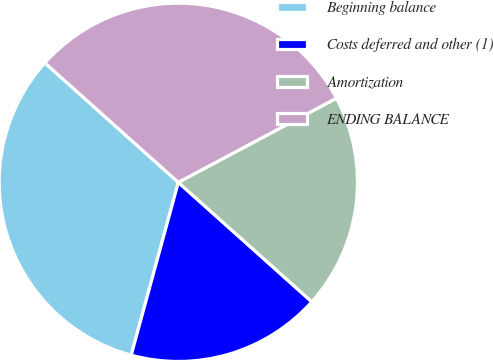<chart> <loc_0><loc_0><loc_500><loc_500><pie_chart><fcel>Beginning balance<fcel>Costs deferred and other (1)<fcel>Amortization<fcel>ENDING BALANCE<nl><fcel>32.38%<fcel>17.62%<fcel>19.4%<fcel>30.6%<nl></chart> 